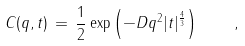Convert formula to latex. <formula><loc_0><loc_0><loc_500><loc_500>C ( q , t ) \, = \, \frac { 1 } { 2 } \exp \left ( - D q ^ { 2 } | t | ^ { \frac { 4 } { 3 } } \right ) \quad ,</formula> 